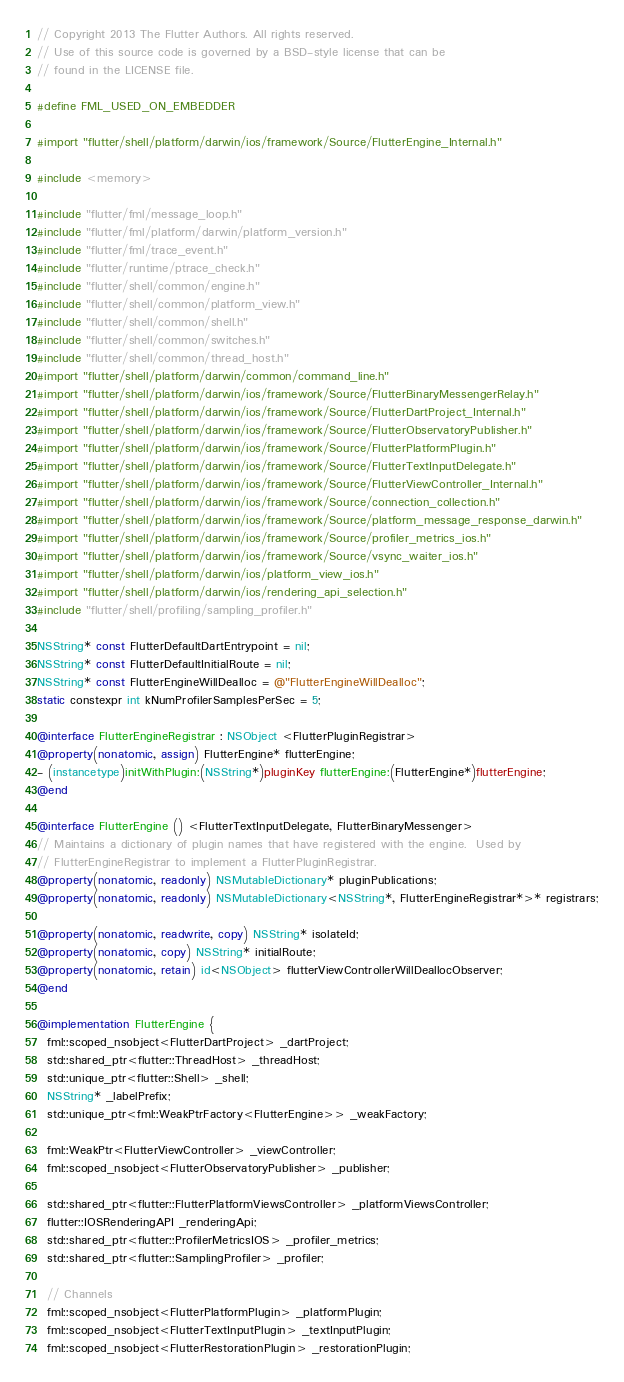Convert code to text. <code><loc_0><loc_0><loc_500><loc_500><_ObjectiveC_>// Copyright 2013 The Flutter Authors. All rights reserved.
// Use of this source code is governed by a BSD-style license that can be
// found in the LICENSE file.

#define FML_USED_ON_EMBEDDER

#import "flutter/shell/platform/darwin/ios/framework/Source/FlutterEngine_Internal.h"

#include <memory>

#include "flutter/fml/message_loop.h"
#include "flutter/fml/platform/darwin/platform_version.h"
#include "flutter/fml/trace_event.h"
#include "flutter/runtime/ptrace_check.h"
#include "flutter/shell/common/engine.h"
#include "flutter/shell/common/platform_view.h"
#include "flutter/shell/common/shell.h"
#include "flutter/shell/common/switches.h"
#include "flutter/shell/common/thread_host.h"
#import "flutter/shell/platform/darwin/common/command_line.h"
#import "flutter/shell/platform/darwin/ios/framework/Source/FlutterBinaryMessengerRelay.h"
#import "flutter/shell/platform/darwin/ios/framework/Source/FlutterDartProject_Internal.h"
#import "flutter/shell/platform/darwin/ios/framework/Source/FlutterObservatoryPublisher.h"
#import "flutter/shell/platform/darwin/ios/framework/Source/FlutterPlatformPlugin.h"
#import "flutter/shell/platform/darwin/ios/framework/Source/FlutterTextInputDelegate.h"
#import "flutter/shell/platform/darwin/ios/framework/Source/FlutterViewController_Internal.h"
#import "flutter/shell/platform/darwin/ios/framework/Source/connection_collection.h"
#import "flutter/shell/platform/darwin/ios/framework/Source/platform_message_response_darwin.h"
#import "flutter/shell/platform/darwin/ios/framework/Source/profiler_metrics_ios.h"
#import "flutter/shell/platform/darwin/ios/framework/Source/vsync_waiter_ios.h"
#import "flutter/shell/platform/darwin/ios/platform_view_ios.h"
#import "flutter/shell/platform/darwin/ios/rendering_api_selection.h"
#include "flutter/shell/profiling/sampling_profiler.h"

NSString* const FlutterDefaultDartEntrypoint = nil;
NSString* const FlutterDefaultInitialRoute = nil;
NSString* const FlutterEngineWillDealloc = @"FlutterEngineWillDealloc";
static constexpr int kNumProfilerSamplesPerSec = 5;

@interface FlutterEngineRegistrar : NSObject <FlutterPluginRegistrar>
@property(nonatomic, assign) FlutterEngine* flutterEngine;
- (instancetype)initWithPlugin:(NSString*)pluginKey flutterEngine:(FlutterEngine*)flutterEngine;
@end

@interface FlutterEngine () <FlutterTextInputDelegate, FlutterBinaryMessenger>
// Maintains a dictionary of plugin names that have registered with the engine.  Used by
// FlutterEngineRegistrar to implement a FlutterPluginRegistrar.
@property(nonatomic, readonly) NSMutableDictionary* pluginPublications;
@property(nonatomic, readonly) NSMutableDictionary<NSString*, FlutterEngineRegistrar*>* registrars;

@property(nonatomic, readwrite, copy) NSString* isolateId;
@property(nonatomic, copy) NSString* initialRoute;
@property(nonatomic, retain) id<NSObject> flutterViewControllerWillDeallocObserver;
@end

@implementation FlutterEngine {
  fml::scoped_nsobject<FlutterDartProject> _dartProject;
  std::shared_ptr<flutter::ThreadHost> _threadHost;
  std::unique_ptr<flutter::Shell> _shell;
  NSString* _labelPrefix;
  std::unique_ptr<fml::WeakPtrFactory<FlutterEngine>> _weakFactory;

  fml::WeakPtr<FlutterViewController> _viewController;
  fml::scoped_nsobject<FlutterObservatoryPublisher> _publisher;

  std::shared_ptr<flutter::FlutterPlatformViewsController> _platformViewsController;
  flutter::IOSRenderingAPI _renderingApi;
  std::shared_ptr<flutter::ProfilerMetricsIOS> _profiler_metrics;
  std::shared_ptr<flutter::SamplingProfiler> _profiler;

  // Channels
  fml::scoped_nsobject<FlutterPlatformPlugin> _platformPlugin;
  fml::scoped_nsobject<FlutterTextInputPlugin> _textInputPlugin;
  fml::scoped_nsobject<FlutterRestorationPlugin> _restorationPlugin;</code> 